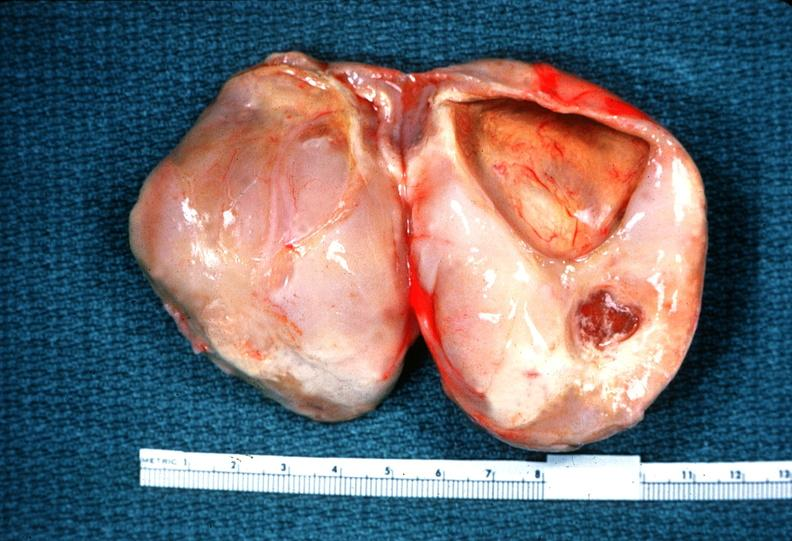does this image show schwannoma?
Answer the question using a single word or phrase. Yes 